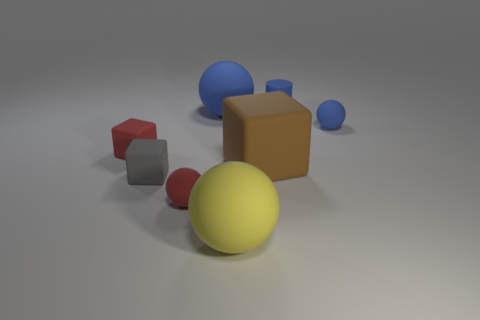There is a small rubber thing that is the same color as the cylinder; what is its shape?
Provide a succinct answer. Sphere. There is a small thing that is to the right of the blue thing behind the blue matte sphere to the left of the blue rubber cylinder; what is its color?
Provide a short and direct response. Blue. There is a rubber sphere that is both behind the brown rubber object and to the left of the tiny blue matte sphere; what is its size?
Offer a very short reply. Large. What number of other things are there of the same shape as the large yellow object?
Offer a very short reply. 3. How many spheres are big red matte things or large yellow objects?
Offer a terse response. 1. Are there any big brown objects in front of the rubber thing in front of the tiny red matte thing in front of the small red matte cube?
Ensure brevity in your answer.  No. What is the color of the other large object that is the same shape as the big blue matte object?
Your response must be concise. Yellow. What number of red things are small cubes or large cylinders?
Offer a very short reply. 1. What is the large sphere that is in front of the red rubber thing that is in front of the gray cube made of?
Make the answer very short. Rubber. Does the yellow thing have the same shape as the tiny gray matte object?
Make the answer very short. No. 